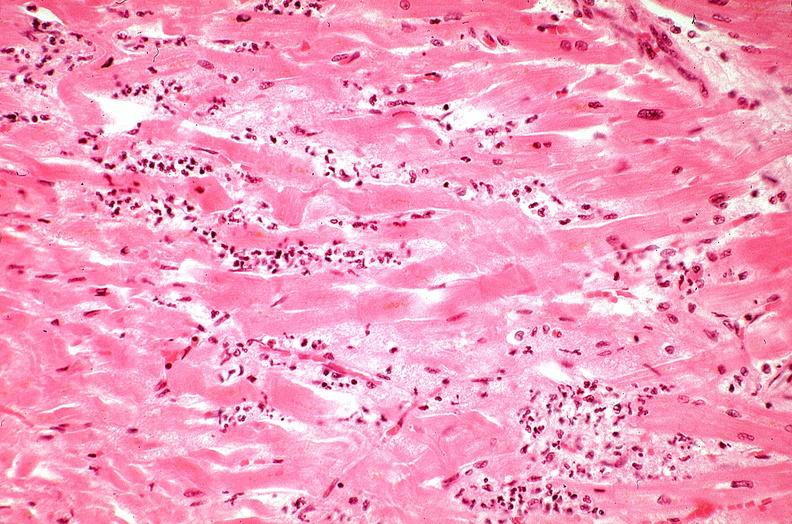s peritoneum present?
Answer the question using a single word or phrase. No 